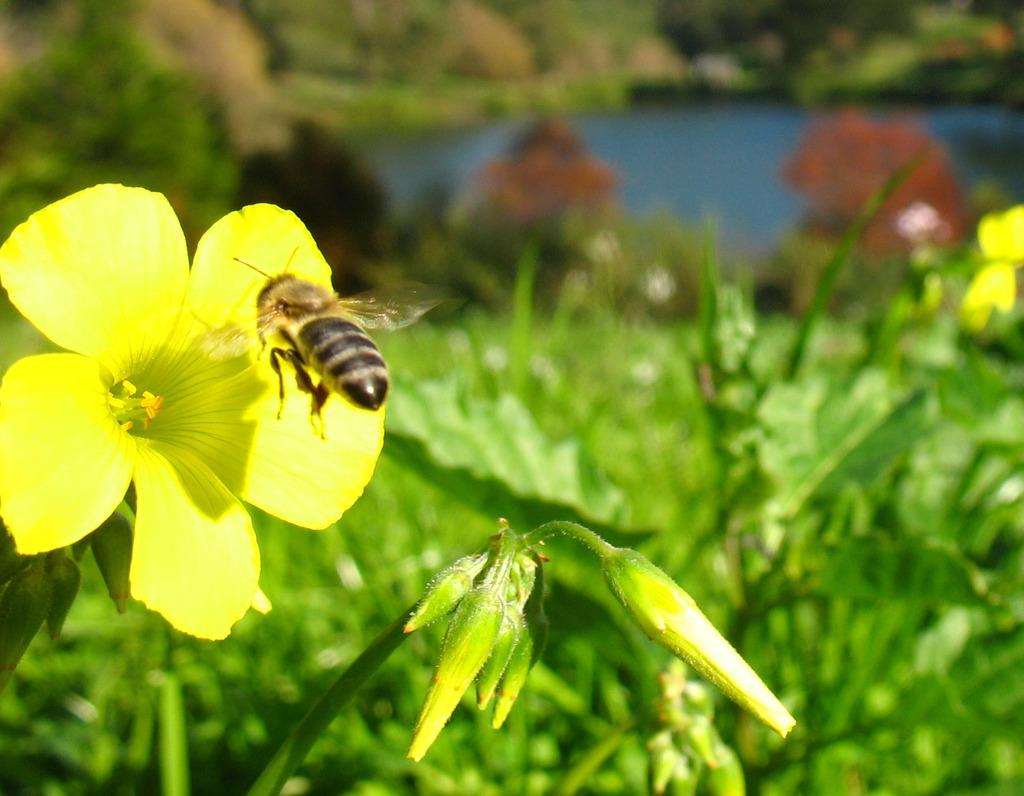What type of plants can be seen in the image? There are flower plants in the image. Are there any animals present in the image? Yes, there is a honey bee in the image. Can you describe the background of the image? The background of the image is blurred. How many dimes are visible on the flower plants in the image? There are no dimes present in the image; it features flower plants and a honey bee. What type of competition is taking place between the flower plants in the image? There is no competition between the flower plants in the image; they are simply growing in their natural environment. 